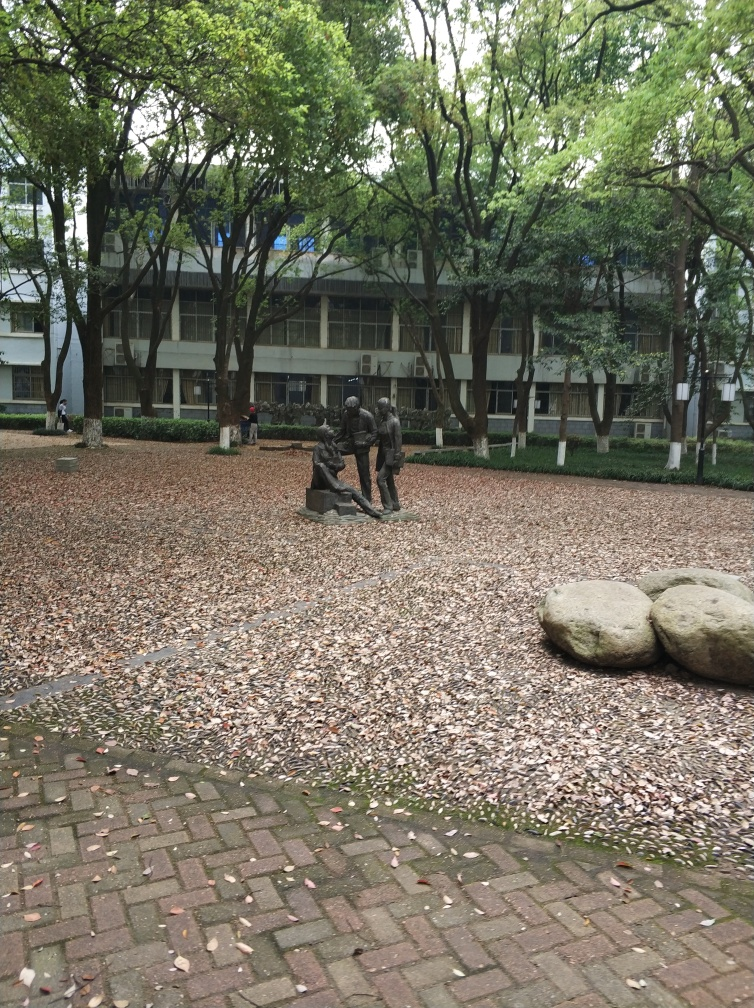Can you tell me more about the focus of the image? The image primarily depicts a statue of multiple figures engaged in what appears to be a group activity or discussion. This artwork is situated in an outdoor setting with numerous trees around it and a ground covered by fallen leaves, likely indicating a scene captured during autumn. The background shows a building, possibly within a campus or a park, which adds context to the location being a public space meant for gatherings and leisure. 